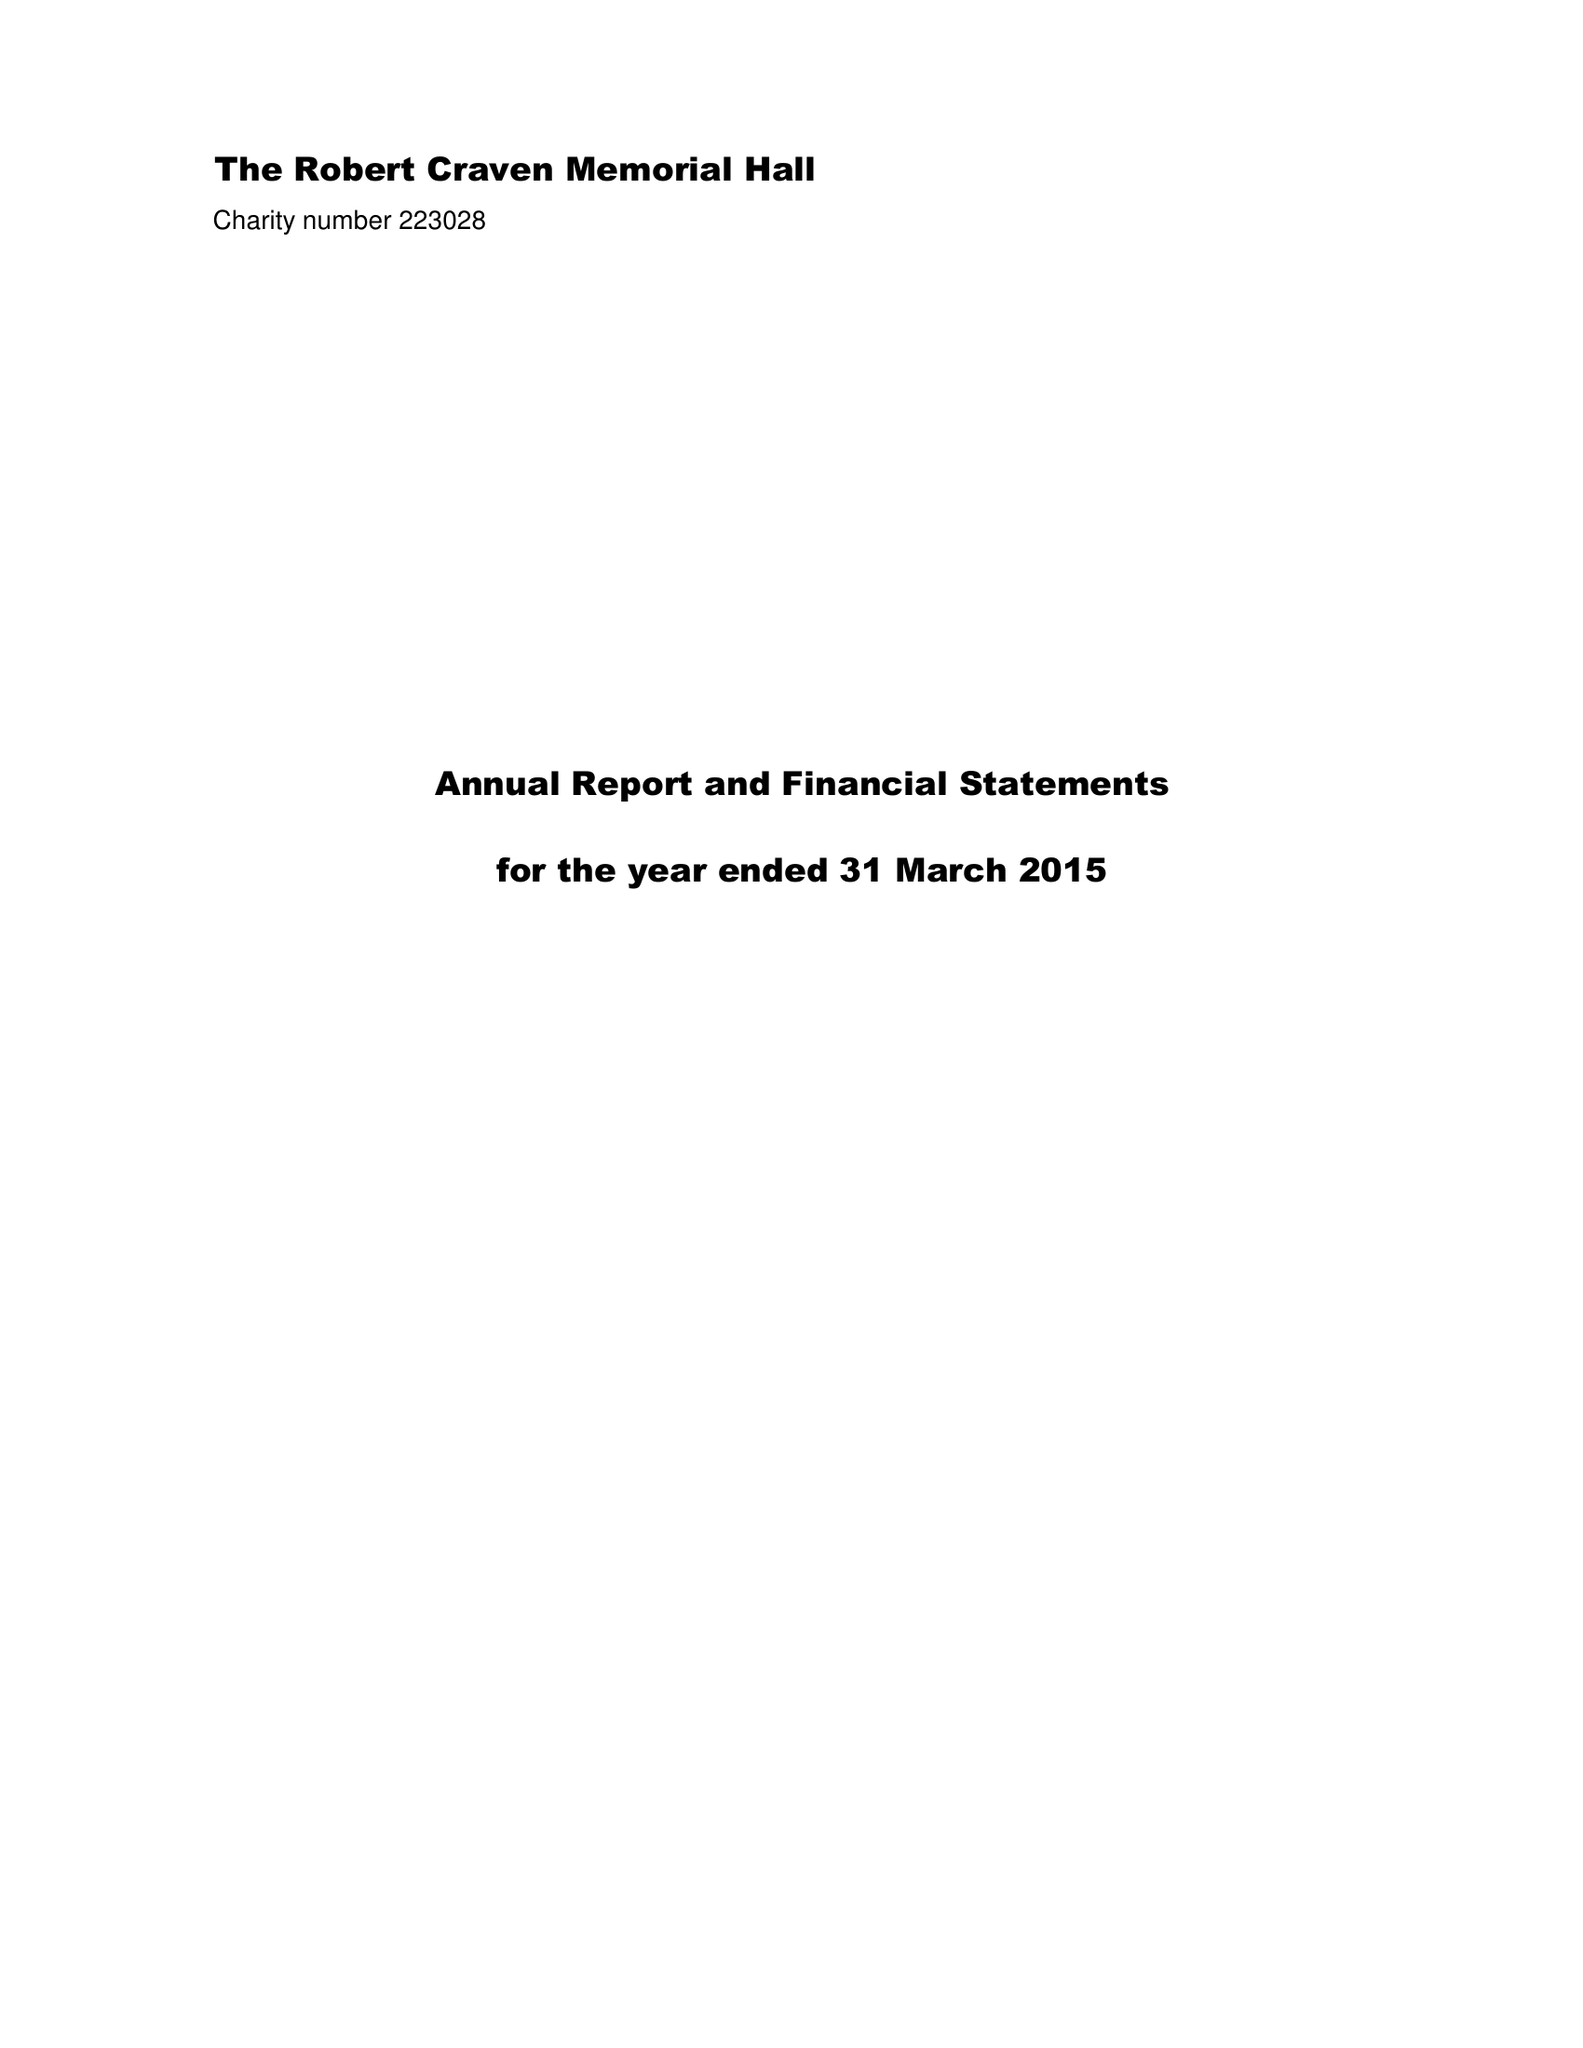What is the value for the charity_name?
Answer the question using a single word or phrase. The Robert Craven Memorial Hall 